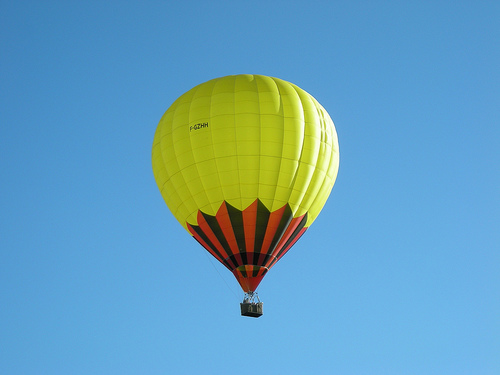<image>
Can you confirm if the balloon is on the sky? Yes. Looking at the image, I can see the balloon is positioned on top of the sky, with the sky providing support. Is the balloon in front of the sky? Yes. The balloon is positioned in front of the sky, appearing closer to the camera viewpoint. 